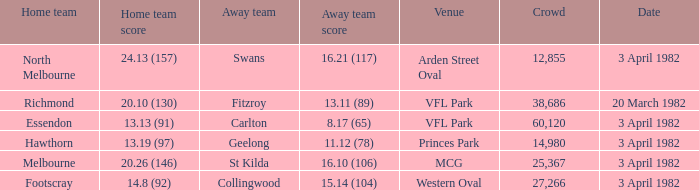When the away team scored 11.12 (78), what was the date of the game? 3 April 1982. 